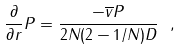Convert formula to latex. <formula><loc_0><loc_0><loc_500><loc_500>\frac { \partial } { \partial r } P = \frac { - \overline { v } P } { 2 N ( 2 - 1 / N ) D } \ ,</formula> 